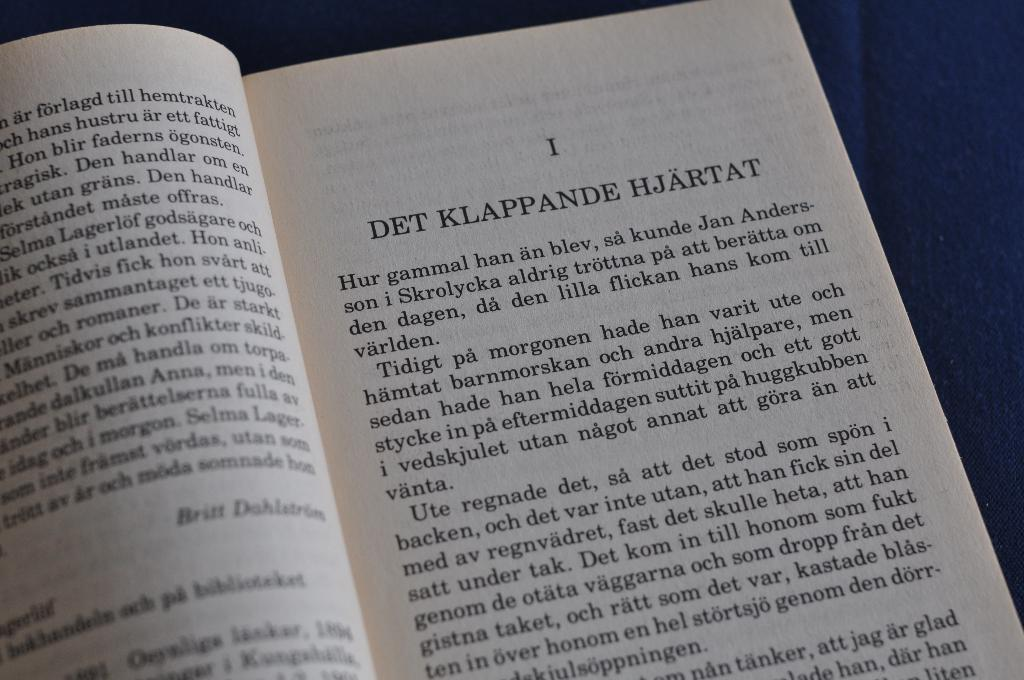<image>
Provide a brief description of the given image. A book is open to the first chapter. 